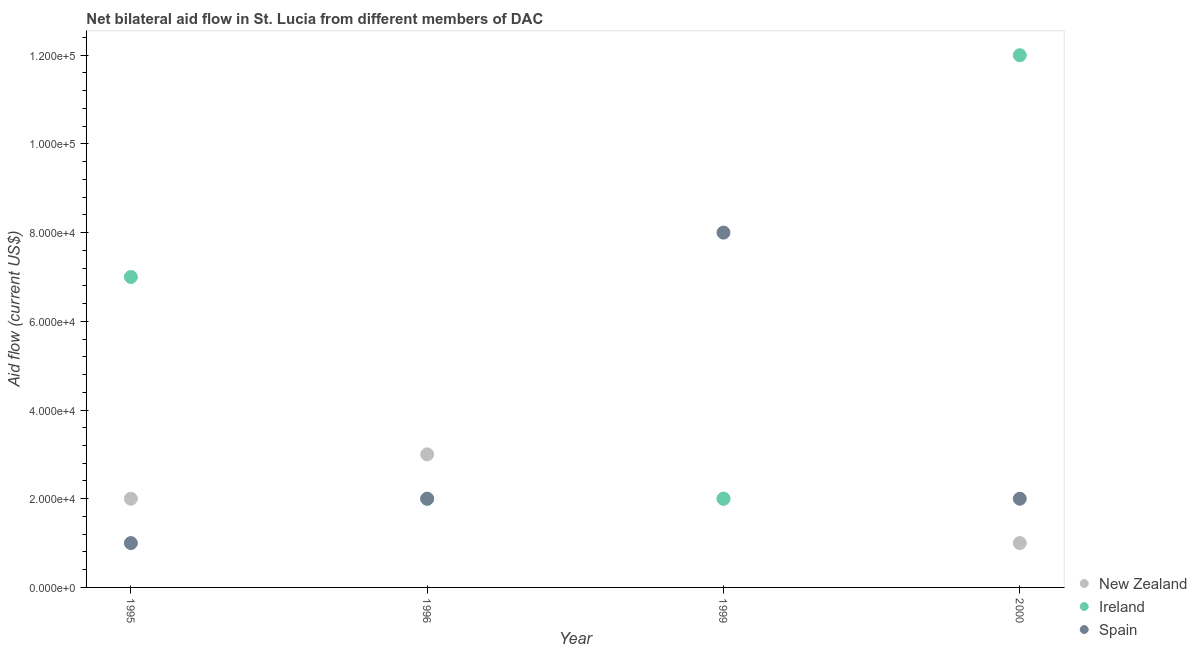What is the amount of aid provided by new zealand in 1996?
Ensure brevity in your answer.  3.00e+04. Across all years, what is the maximum amount of aid provided by spain?
Offer a very short reply. 8.00e+04. Across all years, what is the minimum amount of aid provided by spain?
Keep it short and to the point. 10000. In which year was the amount of aid provided by ireland minimum?
Provide a short and direct response. 1996. What is the total amount of aid provided by ireland in the graph?
Make the answer very short. 2.30e+05. What is the difference between the amount of aid provided by spain in 2000 and the amount of aid provided by new zealand in 1996?
Ensure brevity in your answer.  -10000. What is the average amount of aid provided by ireland per year?
Your answer should be compact. 5.75e+04. In the year 1995, what is the difference between the amount of aid provided by new zealand and amount of aid provided by ireland?
Provide a short and direct response. -5.00e+04. What is the ratio of the amount of aid provided by spain in 1999 to that in 2000?
Your response must be concise. 4. Is the difference between the amount of aid provided by ireland in 1995 and 1996 greater than the difference between the amount of aid provided by new zealand in 1995 and 1996?
Give a very brief answer. Yes. What is the difference between the highest and the second highest amount of aid provided by new zealand?
Your answer should be compact. 10000. What is the difference between the highest and the lowest amount of aid provided by ireland?
Offer a terse response. 1.00e+05. Is the sum of the amount of aid provided by spain in 1996 and 2000 greater than the maximum amount of aid provided by new zealand across all years?
Provide a succinct answer. Yes. How many years are there in the graph?
Your answer should be compact. 4. What is the difference between two consecutive major ticks on the Y-axis?
Give a very brief answer. 2.00e+04. Does the graph contain any zero values?
Make the answer very short. No. How are the legend labels stacked?
Your response must be concise. Vertical. What is the title of the graph?
Give a very brief answer. Net bilateral aid flow in St. Lucia from different members of DAC. What is the label or title of the X-axis?
Keep it short and to the point. Year. What is the label or title of the Y-axis?
Give a very brief answer. Aid flow (current US$). What is the Aid flow (current US$) of Ireland in 1995?
Offer a very short reply. 7.00e+04. What is the Aid flow (current US$) in Ireland in 1996?
Offer a very short reply. 2.00e+04. What is the Aid flow (current US$) of Spain in 1996?
Give a very brief answer. 2.00e+04. What is the Aid flow (current US$) of New Zealand in 1999?
Your answer should be compact. 2.00e+04. What is the Aid flow (current US$) of Ireland in 1999?
Give a very brief answer. 2.00e+04. What is the Aid flow (current US$) in New Zealand in 2000?
Ensure brevity in your answer.  10000. What is the Aid flow (current US$) of Ireland in 2000?
Give a very brief answer. 1.20e+05. What is the Aid flow (current US$) of Spain in 2000?
Your answer should be very brief. 2.00e+04. Across all years, what is the maximum Aid flow (current US$) in Ireland?
Provide a succinct answer. 1.20e+05. What is the total Aid flow (current US$) in New Zealand in the graph?
Ensure brevity in your answer.  8.00e+04. What is the total Aid flow (current US$) of Spain in the graph?
Ensure brevity in your answer.  1.30e+05. What is the difference between the Aid flow (current US$) in New Zealand in 1995 and that in 1996?
Your answer should be very brief. -10000. What is the difference between the Aid flow (current US$) of Ireland in 1995 and that in 1996?
Offer a terse response. 5.00e+04. What is the difference between the Aid flow (current US$) of Ireland in 1995 and that in 1999?
Ensure brevity in your answer.  5.00e+04. What is the difference between the Aid flow (current US$) of New Zealand in 1995 and that in 2000?
Provide a succinct answer. 10000. What is the difference between the Aid flow (current US$) of Ireland in 1995 and that in 2000?
Your answer should be very brief. -5.00e+04. What is the difference between the Aid flow (current US$) of Spain in 1995 and that in 2000?
Your answer should be compact. -10000. What is the difference between the Aid flow (current US$) of New Zealand in 1996 and that in 1999?
Your response must be concise. 10000. What is the difference between the Aid flow (current US$) of Spain in 1996 and that in 1999?
Provide a short and direct response. -6.00e+04. What is the difference between the Aid flow (current US$) of New Zealand in 1996 and that in 2000?
Keep it short and to the point. 2.00e+04. What is the difference between the Aid flow (current US$) in Spain in 1996 and that in 2000?
Provide a short and direct response. 0. What is the difference between the Aid flow (current US$) in New Zealand in 1999 and that in 2000?
Your answer should be very brief. 10000. What is the difference between the Aid flow (current US$) of Ireland in 1999 and that in 2000?
Ensure brevity in your answer.  -1.00e+05. What is the difference between the Aid flow (current US$) of Spain in 1999 and that in 2000?
Keep it short and to the point. 6.00e+04. What is the difference between the Aid flow (current US$) in New Zealand in 1995 and the Aid flow (current US$) in Ireland in 1996?
Provide a short and direct response. 0. What is the difference between the Aid flow (current US$) of Ireland in 1995 and the Aid flow (current US$) of Spain in 2000?
Keep it short and to the point. 5.00e+04. What is the difference between the Aid flow (current US$) in New Zealand in 1996 and the Aid flow (current US$) in Spain in 1999?
Ensure brevity in your answer.  -5.00e+04. What is the difference between the Aid flow (current US$) in New Zealand in 1996 and the Aid flow (current US$) in Spain in 2000?
Give a very brief answer. 10000. What is the difference between the Aid flow (current US$) in New Zealand in 1999 and the Aid flow (current US$) in Ireland in 2000?
Make the answer very short. -1.00e+05. What is the average Aid flow (current US$) of New Zealand per year?
Your answer should be compact. 2.00e+04. What is the average Aid flow (current US$) of Ireland per year?
Provide a short and direct response. 5.75e+04. What is the average Aid flow (current US$) of Spain per year?
Provide a short and direct response. 3.25e+04. In the year 1995, what is the difference between the Aid flow (current US$) in New Zealand and Aid flow (current US$) in Ireland?
Provide a short and direct response. -5.00e+04. In the year 1995, what is the difference between the Aid flow (current US$) of New Zealand and Aid flow (current US$) of Spain?
Provide a short and direct response. 10000. In the year 1995, what is the difference between the Aid flow (current US$) of Ireland and Aid flow (current US$) of Spain?
Provide a short and direct response. 6.00e+04. In the year 1996, what is the difference between the Aid flow (current US$) in New Zealand and Aid flow (current US$) in Spain?
Your response must be concise. 10000. In the year 1996, what is the difference between the Aid flow (current US$) in Ireland and Aid flow (current US$) in Spain?
Provide a short and direct response. 0. In the year 1999, what is the difference between the Aid flow (current US$) in New Zealand and Aid flow (current US$) in Spain?
Your answer should be very brief. -6.00e+04. In the year 1999, what is the difference between the Aid flow (current US$) in Ireland and Aid flow (current US$) in Spain?
Offer a very short reply. -6.00e+04. What is the ratio of the Aid flow (current US$) of New Zealand in 1995 to that in 1996?
Keep it short and to the point. 0.67. What is the ratio of the Aid flow (current US$) in Ireland in 1995 to that in 1996?
Give a very brief answer. 3.5. What is the ratio of the Aid flow (current US$) in New Zealand in 1995 to that in 1999?
Keep it short and to the point. 1. What is the ratio of the Aid flow (current US$) in Spain in 1995 to that in 1999?
Offer a very short reply. 0.12. What is the ratio of the Aid flow (current US$) of Ireland in 1995 to that in 2000?
Your answer should be compact. 0.58. What is the ratio of the Aid flow (current US$) of Spain in 1995 to that in 2000?
Ensure brevity in your answer.  0.5. What is the ratio of the Aid flow (current US$) of Ireland in 1996 to that in 1999?
Your response must be concise. 1. What is the ratio of the Aid flow (current US$) in New Zealand in 1996 to that in 2000?
Provide a succinct answer. 3. What is the ratio of the Aid flow (current US$) in Ireland in 1996 to that in 2000?
Keep it short and to the point. 0.17. What is the ratio of the Aid flow (current US$) of Spain in 1996 to that in 2000?
Provide a short and direct response. 1. What is the ratio of the Aid flow (current US$) of New Zealand in 1999 to that in 2000?
Provide a succinct answer. 2. What is the difference between the highest and the second highest Aid flow (current US$) of New Zealand?
Provide a short and direct response. 10000. What is the difference between the highest and the second highest Aid flow (current US$) of Ireland?
Provide a succinct answer. 5.00e+04. What is the difference between the highest and the second highest Aid flow (current US$) of Spain?
Provide a short and direct response. 6.00e+04. What is the difference between the highest and the lowest Aid flow (current US$) in New Zealand?
Offer a terse response. 2.00e+04. 